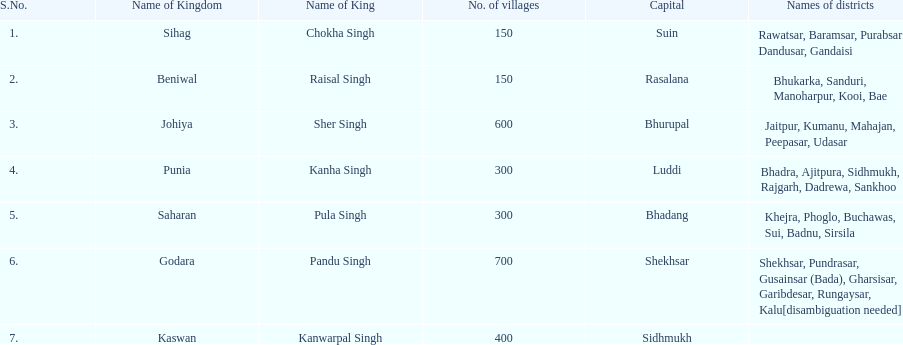Which kingdom contained the second most villages, next only to godara? Johiya. 